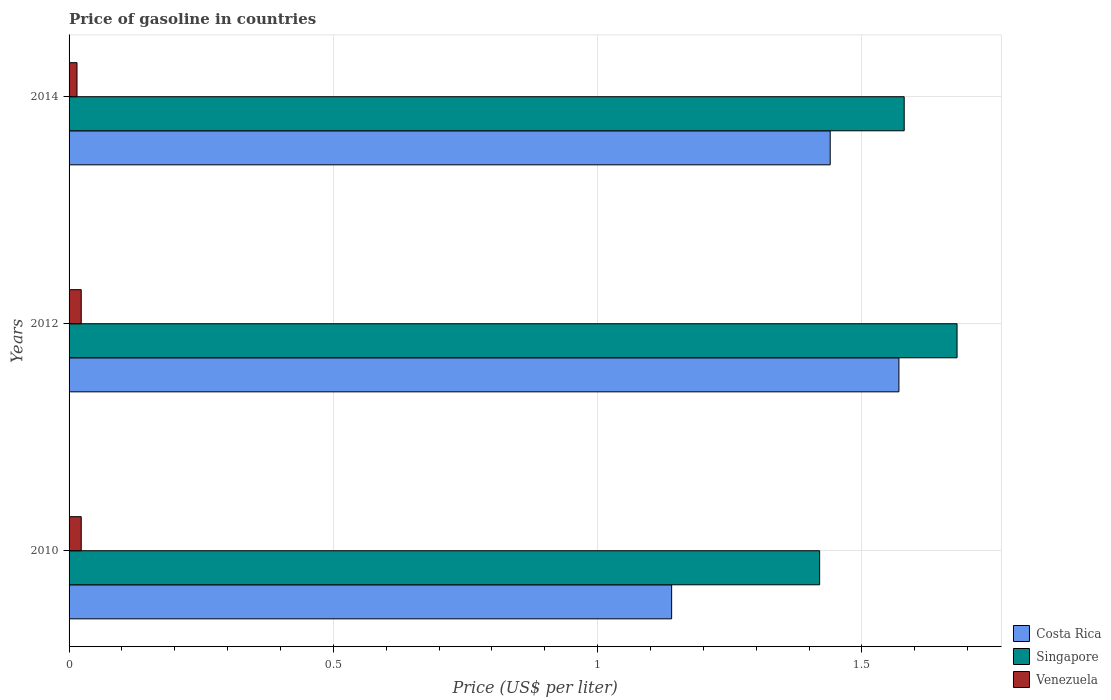How many different coloured bars are there?
Make the answer very short. 3. How many groups of bars are there?
Keep it short and to the point. 3. Are the number of bars on each tick of the Y-axis equal?
Your response must be concise. Yes. How many bars are there on the 3rd tick from the top?
Make the answer very short. 3. How many bars are there on the 2nd tick from the bottom?
Provide a succinct answer. 3. What is the label of the 3rd group of bars from the top?
Give a very brief answer. 2010. What is the price of gasoline in Venezuela in 2012?
Ensure brevity in your answer.  0.02. Across all years, what is the maximum price of gasoline in Venezuela?
Ensure brevity in your answer.  0.02. Across all years, what is the minimum price of gasoline in Costa Rica?
Offer a very short reply. 1.14. In which year was the price of gasoline in Singapore maximum?
Your answer should be compact. 2012. What is the total price of gasoline in Singapore in the graph?
Ensure brevity in your answer.  4.68. What is the difference between the price of gasoline in Singapore in 2010 and that in 2014?
Make the answer very short. -0.16. What is the difference between the price of gasoline in Venezuela in 2010 and the price of gasoline in Singapore in 2014?
Make the answer very short. -1.56. What is the average price of gasoline in Singapore per year?
Offer a terse response. 1.56. In the year 2012, what is the difference between the price of gasoline in Costa Rica and price of gasoline in Singapore?
Ensure brevity in your answer.  -0.11. What is the ratio of the price of gasoline in Costa Rica in 2012 to that in 2014?
Your response must be concise. 1.09. Is the price of gasoline in Singapore in 2010 less than that in 2014?
Keep it short and to the point. Yes. What is the difference between the highest and the second highest price of gasoline in Costa Rica?
Ensure brevity in your answer.  0.13. What is the difference between the highest and the lowest price of gasoline in Costa Rica?
Provide a succinct answer. 0.43. In how many years, is the price of gasoline in Venezuela greater than the average price of gasoline in Venezuela taken over all years?
Offer a terse response. 2. What does the 1st bar from the top in 2014 represents?
Your answer should be compact. Venezuela. What does the 3rd bar from the bottom in 2012 represents?
Your response must be concise. Venezuela. Is it the case that in every year, the sum of the price of gasoline in Venezuela and price of gasoline in Costa Rica is greater than the price of gasoline in Singapore?
Make the answer very short. No. Are all the bars in the graph horizontal?
Your answer should be compact. Yes. What is the difference between two consecutive major ticks on the X-axis?
Your answer should be compact. 0.5. Does the graph contain grids?
Your answer should be compact. Yes. Where does the legend appear in the graph?
Make the answer very short. Bottom right. How many legend labels are there?
Provide a succinct answer. 3. What is the title of the graph?
Make the answer very short. Price of gasoline in countries. What is the label or title of the X-axis?
Your answer should be very brief. Price (US$ per liter). What is the Price (US$ per liter) of Costa Rica in 2010?
Keep it short and to the point. 1.14. What is the Price (US$ per liter) in Singapore in 2010?
Provide a short and direct response. 1.42. What is the Price (US$ per liter) in Venezuela in 2010?
Offer a terse response. 0.02. What is the Price (US$ per liter) in Costa Rica in 2012?
Offer a terse response. 1.57. What is the Price (US$ per liter) in Singapore in 2012?
Provide a short and direct response. 1.68. What is the Price (US$ per liter) in Venezuela in 2012?
Offer a very short reply. 0.02. What is the Price (US$ per liter) of Costa Rica in 2014?
Provide a succinct answer. 1.44. What is the Price (US$ per liter) of Singapore in 2014?
Provide a succinct answer. 1.58. What is the Price (US$ per liter) in Venezuela in 2014?
Your answer should be very brief. 0.01. Across all years, what is the maximum Price (US$ per liter) in Costa Rica?
Your answer should be compact. 1.57. Across all years, what is the maximum Price (US$ per liter) of Singapore?
Keep it short and to the point. 1.68. Across all years, what is the maximum Price (US$ per liter) of Venezuela?
Offer a very short reply. 0.02. Across all years, what is the minimum Price (US$ per liter) of Costa Rica?
Ensure brevity in your answer.  1.14. Across all years, what is the minimum Price (US$ per liter) in Singapore?
Provide a short and direct response. 1.42. Across all years, what is the minimum Price (US$ per liter) in Venezuela?
Your response must be concise. 0.01. What is the total Price (US$ per liter) of Costa Rica in the graph?
Provide a succinct answer. 4.15. What is the total Price (US$ per liter) in Singapore in the graph?
Provide a succinct answer. 4.68. What is the total Price (US$ per liter) in Venezuela in the graph?
Your response must be concise. 0.06. What is the difference between the Price (US$ per liter) in Costa Rica in 2010 and that in 2012?
Your response must be concise. -0.43. What is the difference between the Price (US$ per liter) of Singapore in 2010 and that in 2012?
Your response must be concise. -0.26. What is the difference between the Price (US$ per liter) of Costa Rica in 2010 and that in 2014?
Provide a succinct answer. -0.3. What is the difference between the Price (US$ per liter) in Singapore in 2010 and that in 2014?
Give a very brief answer. -0.16. What is the difference between the Price (US$ per liter) of Venezuela in 2010 and that in 2014?
Your response must be concise. 0.01. What is the difference between the Price (US$ per liter) of Costa Rica in 2012 and that in 2014?
Offer a terse response. 0.13. What is the difference between the Price (US$ per liter) of Venezuela in 2012 and that in 2014?
Offer a terse response. 0.01. What is the difference between the Price (US$ per liter) in Costa Rica in 2010 and the Price (US$ per liter) in Singapore in 2012?
Provide a short and direct response. -0.54. What is the difference between the Price (US$ per liter) in Costa Rica in 2010 and the Price (US$ per liter) in Venezuela in 2012?
Ensure brevity in your answer.  1.12. What is the difference between the Price (US$ per liter) of Singapore in 2010 and the Price (US$ per liter) of Venezuela in 2012?
Provide a succinct answer. 1.4. What is the difference between the Price (US$ per liter) in Costa Rica in 2010 and the Price (US$ per liter) in Singapore in 2014?
Make the answer very short. -0.44. What is the difference between the Price (US$ per liter) of Costa Rica in 2010 and the Price (US$ per liter) of Venezuela in 2014?
Provide a short and direct response. 1.12. What is the difference between the Price (US$ per liter) of Singapore in 2010 and the Price (US$ per liter) of Venezuela in 2014?
Ensure brevity in your answer.  1.41. What is the difference between the Price (US$ per liter) of Costa Rica in 2012 and the Price (US$ per liter) of Singapore in 2014?
Your answer should be very brief. -0.01. What is the difference between the Price (US$ per liter) of Costa Rica in 2012 and the Price (US$ per liter) of Venezuela in 2014?
Provide a short and direct response. 1.55. What is the difference between the Price (US$ per liter) in Singapore in 2012 and the Price (US$ per liter) in Venezuela in 2014?
Make the answer very short. 1.67. What is the average Price (US$ per liter) in Costa Rica per year?
Offer a terse response. 1.38. What is the average Price (US$ per liter) in Singapore per year?
Your response must be concise. 1.56. What is the average Price (US$ per liter) in Venezuela per year?
Ensure brevity in your answer.  0.02. In the year 2010, what is the difference between the Price (US$ per liter) in Costa Rica and Price (US$ per liter) in Singapore?
Offer a very short reply. -0.28. In the year 2010, what is the difference between the Price (US$ per liter) of Costa Rica and Price (US$ per liter) of Venezuela?
Your response must be concise. 1.12. In the year 2010, what is the difference between the Price (US$ per liter) of Singapore and Price (US$ per liter) of Venezuela?
Give a very brief answer. 1.4. In the year 2012, what is the difference between the Price (US$ per liter) in Costa Rica and Price (US$ per liter) in Singapore?
Provide a short and direct response. -0.11. In the year 2012, what is the difference between the Price (US$ per liter) in Costa Rica and Price (US$ per liter) in Venezuela?
Your answer should be very brief. 1.55. In the year 2012, what is the difference between the Price (US$ per liter) in Singapore and Price (US$ per liter) in Venezuela?
Your answer should be compact. 1.66. In the year 2014, what is the difference between the Price (US$ per liter) in Costa Rica and Price (US$ per liter) in Singapore?
Offer a very short reply. -0.14. In the year 2014, what is the difference between the Price (US$ per liter) in Costa Rica and Price (US$ per liter) in Venezuela?
Your answer should be very brief. 1.43. In the year 2014, what is the difference between the Price (US$ per liter) of Singapore and Price (US$ per liter) of Venezuela?
Your response must be concise. 1.56. What is the ratio of the Price (US$ per liter) in Costa Rica in 2010 to that in 2012?
Ensure brevity in your answer.  0.73. What is the ratio of the Price (US$ per liter) in Singapore in 2010 to that in 2012?
Give a very brief answer. 0.85. What is the ratio of the Price (US$ per liter) in Venezuela in 2010 to that in 2012?
Your answer should be very brief. 1. What is the ratio of the Price (US$ per liter) of Costa Rica in 2010 to that in 2014?
Provide a succinct answer. 0.79. What is the ratio of the Price (US$ per liter) of Singapore in 2010 to that in 2014?
Your response must be concise. 0.9. What is the ratio of the Price (US$ per liter) of Venezuela in 2010 to that in 2014?
Offer a very short reply. 1.53. What is the ratio of the Price (US$ per liter) in Costa Rica in 2012 to that in 2014?
Offer a terse response. 1.09. What is the ratio of the Price (US$ per liter) of Singapore in 2012 to that in 2014?
Ensure brevity in your answer.  1.06. What is the ratio of the Price (US$ per liter) in Venezuela in 2012 to that in 2014?
Your answer should be compact. 1.53. What is the difference between the highest and the second highest Price (US$ per liter) of Costa Rica?
Your answer should be compact. 0.13. What is the difference between the highest and the lowest Price (US$ per liter) of Costa Rica?
Give a very brief answer. 0.43. What is the difference between the highest and the lowest Price (US$ per liter) of Singapore?
Offer a terse response. 0.26. What is the difference between the highest and the lowest Price (US$ per liter) of Venezuela?
Your response must be concise. 0.01. 